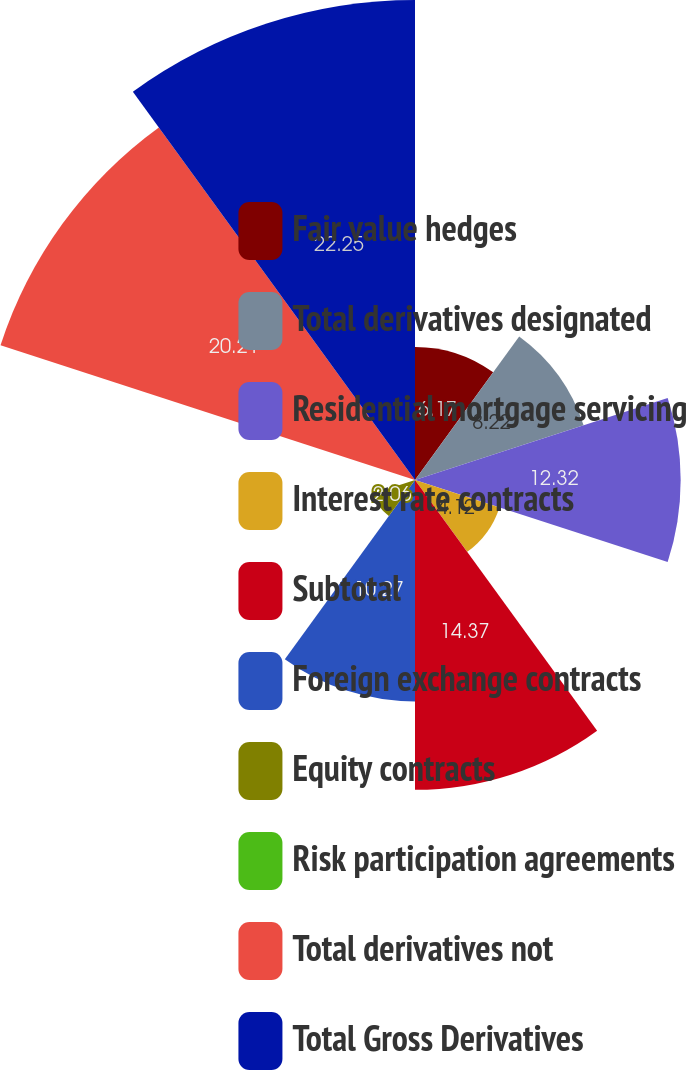Convert chart. <chart><loc_0><loc_0><loc_500><loc_500><pie_chart><fcel>Fair value hedges<fcel>Total derivatives designated<fcel>Residential mortgage servicing<fcel>Interest rate contracts<fcel>Subtotal<fcel>Foreign exchange contracts<fcel>Equity contracts<fcel>Risk participation agreements<fcel>Total derivatives not<fcel>Total Gross Derivatives<nl><fcel>6.17%<fcel>8.22%<fcel>12.32%<fcel>4.12%<fcel>14.37%<fcel>10.27%<fcel>2.06%<fcel>0.01%<fcel>20.21%<fcel>22.26%<nl></chart> 